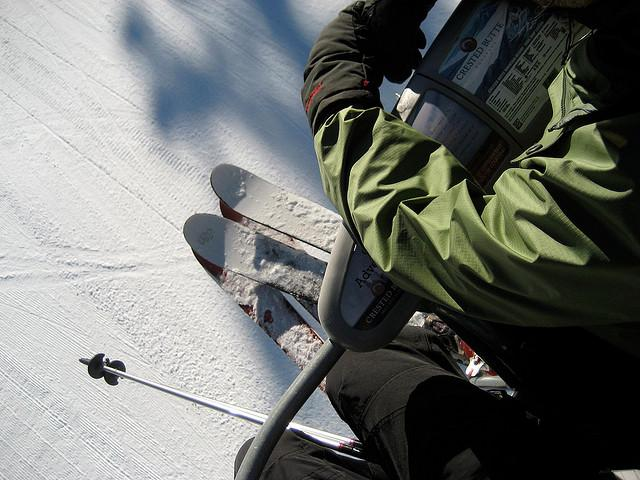What is the person near?

Choices:
A) bed
B) table
C) ski poles
D) cow ski poles 